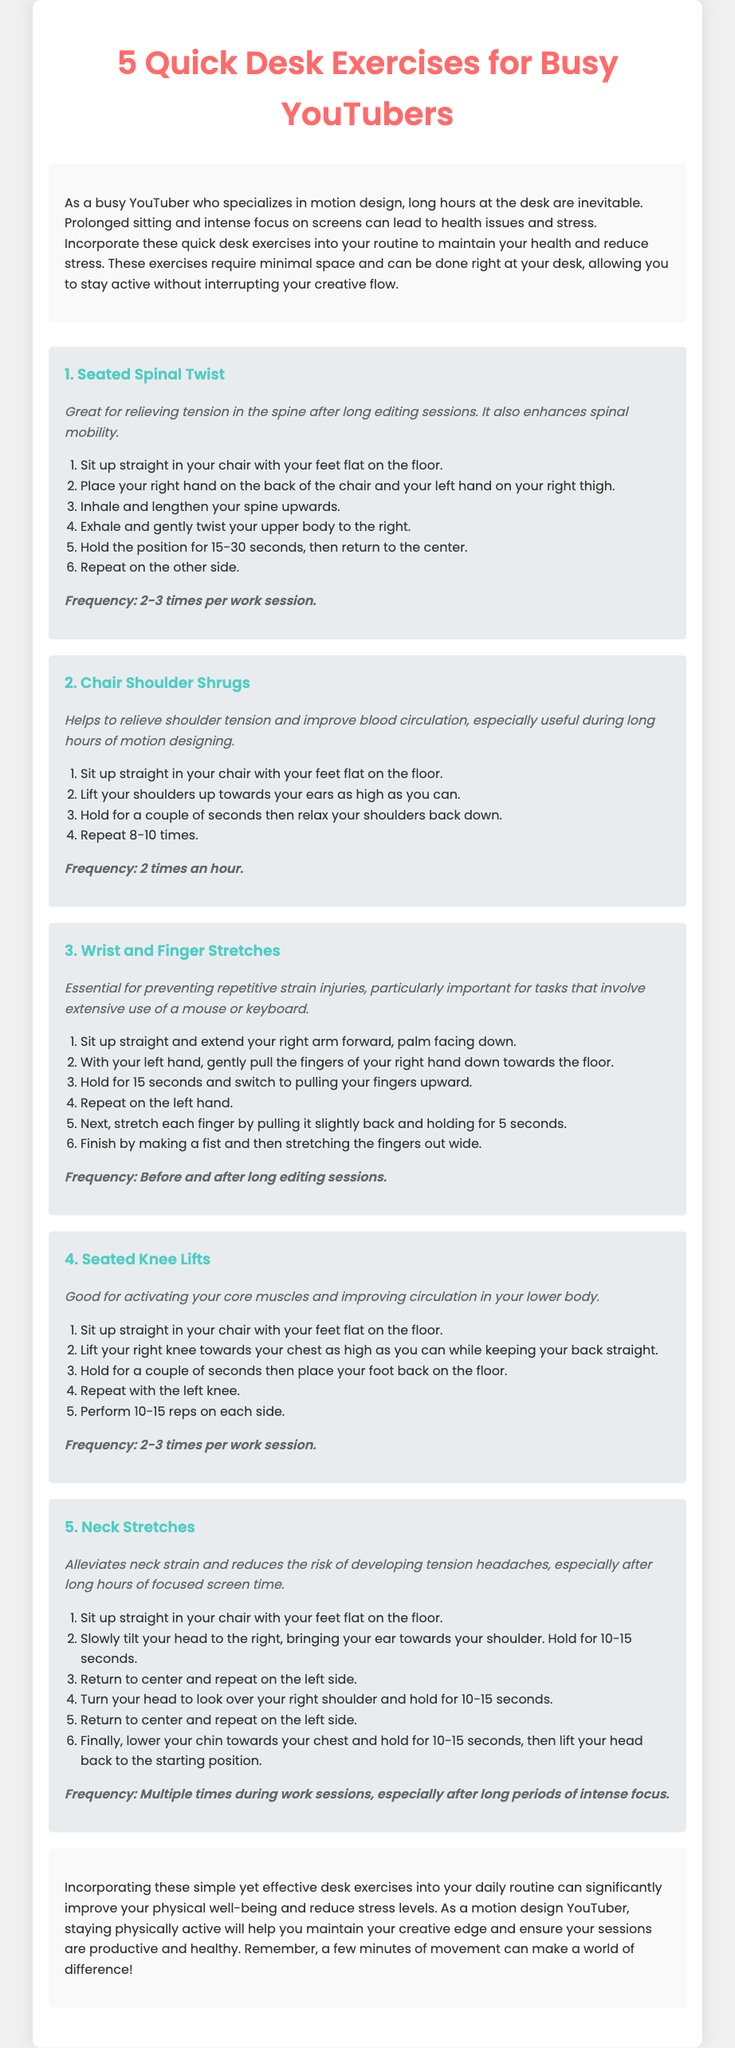What is the title of the document? The title is the main heading located at the top of the document that indicates the content, which is "5 Quick Desk Exercises for Busy YouTubers."
Answer: 5 Quick Desk Exercises for Busy YouTubers How many exercises are described in the document? The total number of exercises is stated at the beginning of the list of exercises, which is five.
Answer: 5 What is the purpose of the "Seated Spinal Twist"? The purpose is to describe its benefits, which are "relieving tension in the spine after long editing sessions" and "enhancing spinal mobility."
Answer: Relieving tension How often should "Chair Shoulder Shrugs" be performed? The frequency mentioned in the document indicates how many times these should be done within a specific timeframe, which is two times an hour.
Answer: 2 times an hour What exercise helps prevent repetitive strain injuries? The document explicitly mentions "Wrist and Finger Stretches" as essential for preventing these injuries.
Answer: Wrist and Finger Stretches What is one benefit of "Neck Stretches"? The document states one benefit is "alleviating neck strain and reducing the risk of developing tension headaches."
Answer: Alleviates neck strain Which exercise is recommended for activating core muscles? The document specifically names "Seated Knee Lifts" as good for activating core muscles.
Answer: Seated Knee Lifts How long should "Wrist and Finger Stretches" be held? The document specifies that each stretch should be held for a duration of 15 seconds.
Answer: 15 seconds What should be done before and after long editing sessions? The document recommends performing "Wrist and Finger Stretches" before and after these sessions.
Answer: Wrist and Finger Stretches 